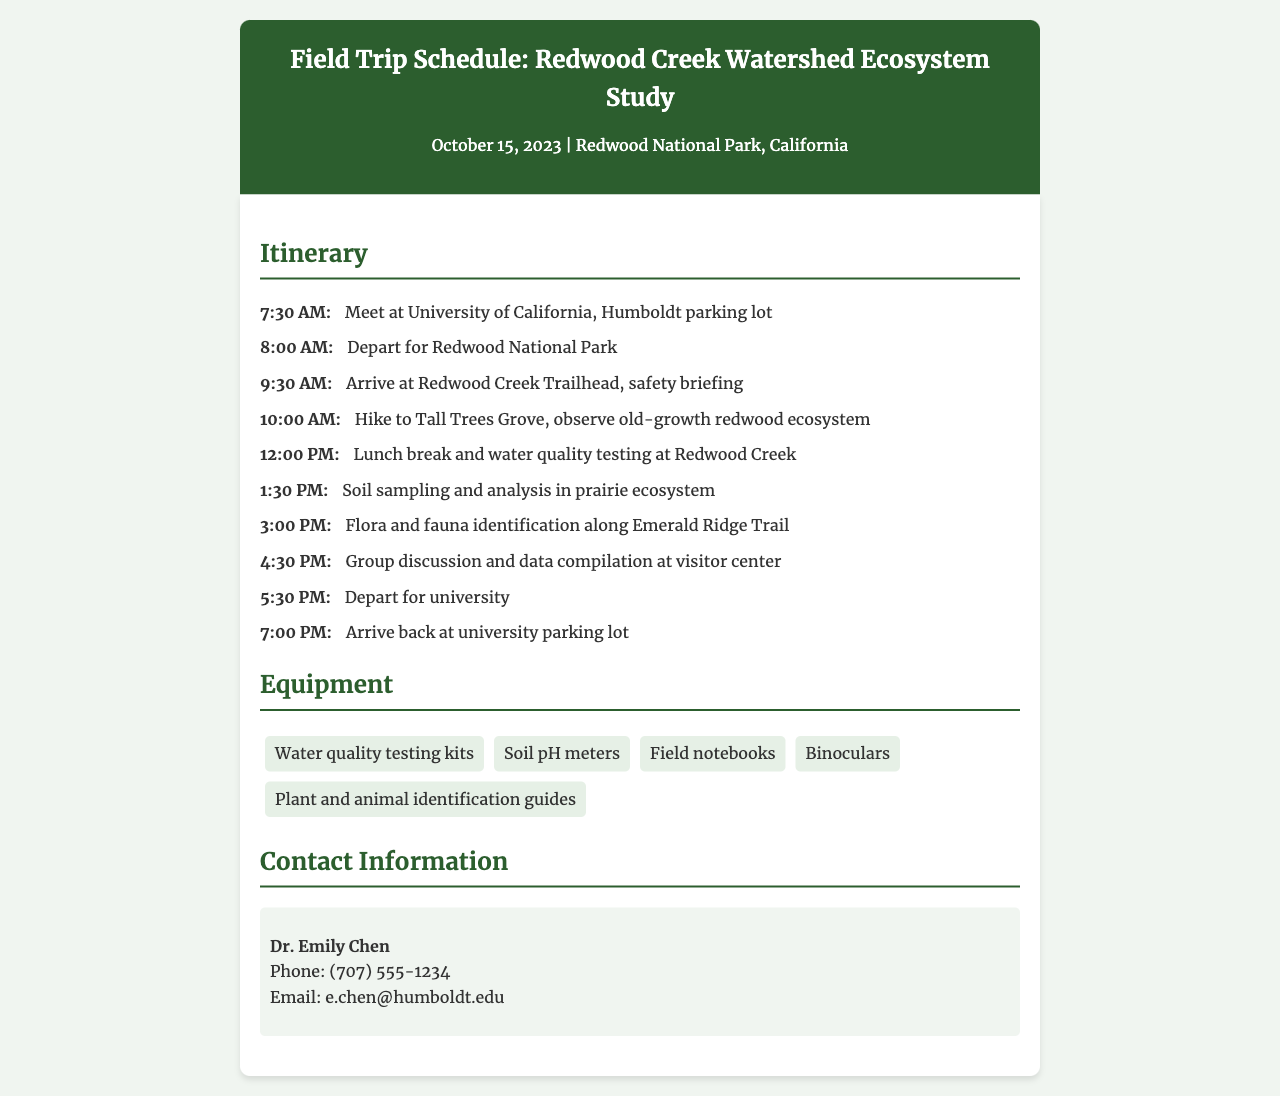What is the title of the field trip? The title is stated in the header of the document.
Answer: Field Trip Schedule: Redwood Creek Watershed Ecosystem Study When is the field trip scheduled? The date is mentioned in the subheader of the document.
Answer: October 15, 2023 Where will the students meet? The meeting point is specified in the itinerary section of the document.
Answer: University of California, Humboldt parking lot What time will the group depart for Redwood National Park? The departure time is noted in the itinerary.
Answer: 8:00 AM What activity will take place at 12:00 PM? The itinerary lists the activities scheduled at that time.
Answer: Lunch break and water quality testing at Redwood Creek How many pieces of equipment are listed for the trip? The total number of equipment items can be counted from the Equipment section.
Answer: 5 Who is the contact person for the field trip? The contact information section provides the name of the contact person.
Answer: Dr. Emily Chen What is the phone number provided in the contact information? The phone number is specifically mentioned in the contact information section.
Answer: (707) 555-1234 What will happen at 4:30 PM during the trip? The itinerary outlines the activities for that time.
Answer: Group discussion and data compilation at visitor center 